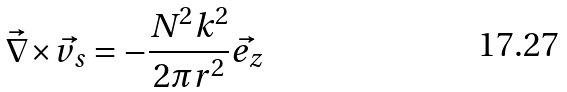Convert formula to latex. <formula><loc_0><loc_0><loc_500><loc_500>\vec { \nabla } { \times } \vec { v _ { s } } = - \frac { N ^ { 2 } k ^ { 2 } } { 2 { \pi } r ^ { 2 } } { \vec { e _ { z } } }</formula> 